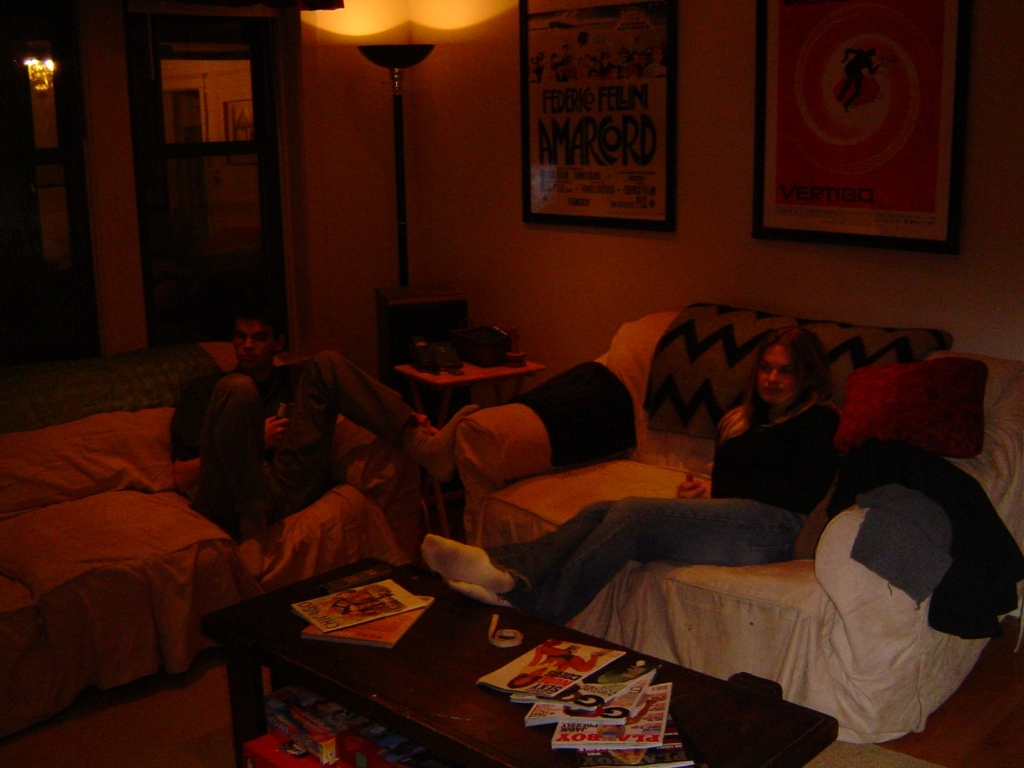Are there any specific activities the people in the photo appear to be engaged in? The individuals in the photo appear to be engaged in casual, leisurely activities. One person seems to be holding a remote, which could imply they were watching television or about to choose a film. Their relaxed body language and comfortable seating suggest they are spending downtime, possibly enjoying a movie night or simply hanging out together. What can you say about the relationship between the two individuals? While it's challenging to ascertain the precise nature of their relationship from a single image, their comfortable body language and shared space convey a sense of familiarity and ease with each other. This comfort could indicate they are good friends, roommates, or family members who share a close bond. 